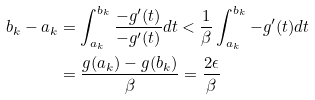<formula> <loc_0><loc_0><loc_500><loc_500>b _ { k } - a _ { k } & = \int _ { a _ { k } } ^ { b _ { k } } \frac { - g ^ { \prime } ( t ) } { - g ^ { \prime } ( t ) } d t < \frac { 1 } { \beta } \int _ { a _ { k } } ^ { b _ { k } } - g ^ { \prime } ( t ) d t \\ & = \frac { g ( a _ { k } ) - g ( b _ { k } ) } { \beta } = \frac { 2 \epsilon } { \beta }</formula> 